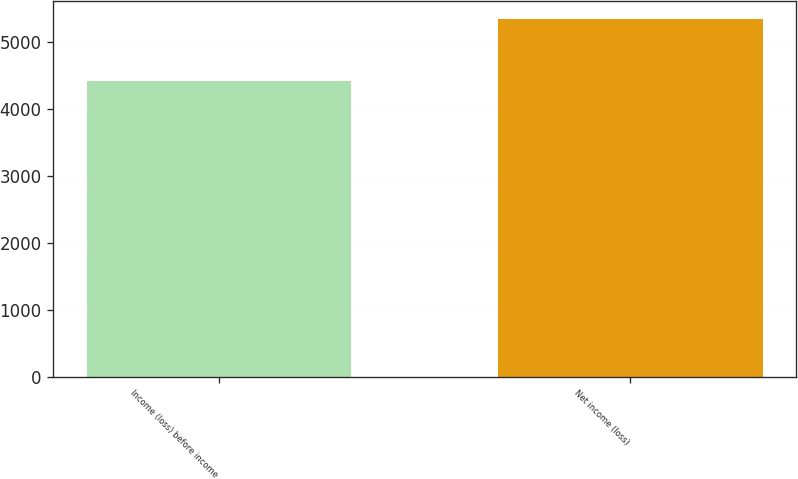Convert chart. <chart><loc_0><loc_0><loc_500><loc_500><bar_chart><fcel>Income (loss) before income<fcel>Net income (loss)<nl><fcel>4416<fcel>5346<nl></chart> 